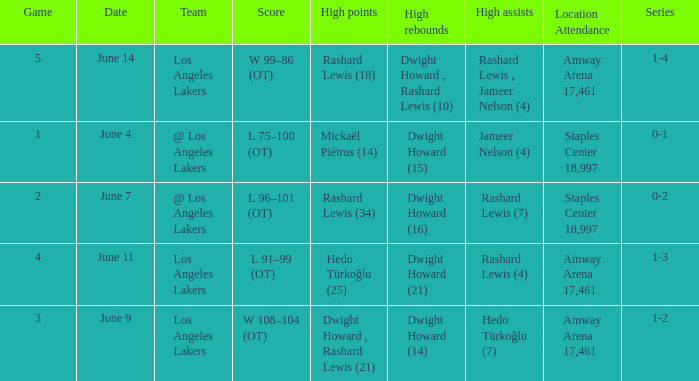What is High Assists, when High Rebounds is "Dwight Howard , Rashard Lewis (10)"? Rashard Lewis , Jameer Nelson (4). 